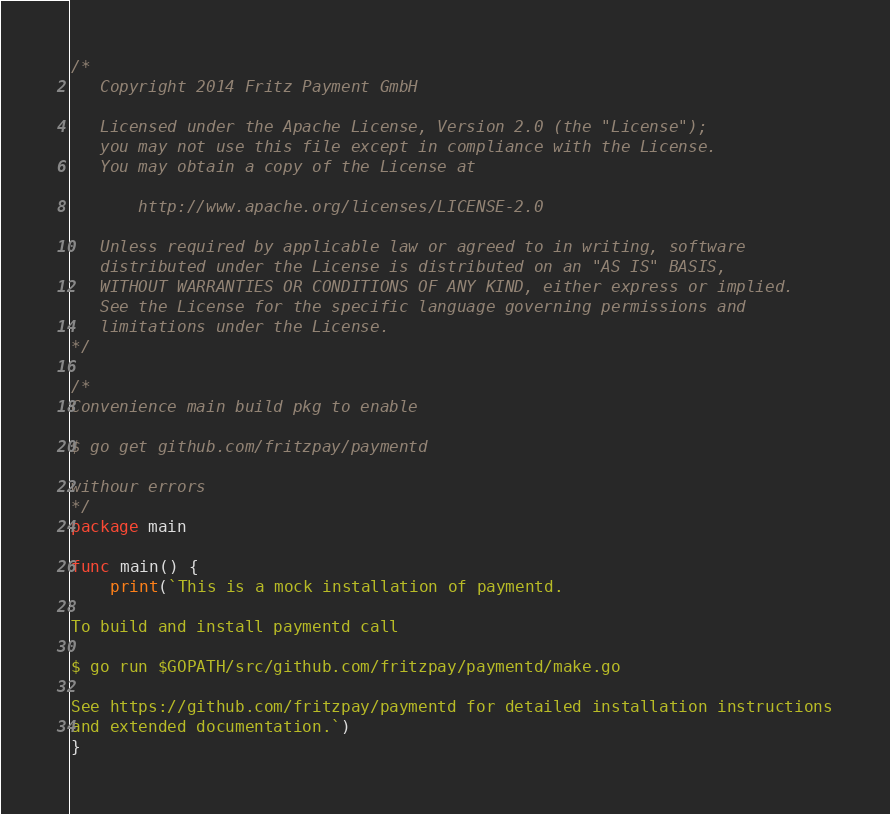Convert code to text. <code><loc_0><loc_0><loc_500><loc_500><_Go_>/*
   Copyright 2014 Fritz Payment GmbH

   Licensed under the Apache License, Version 2.0 (the "License");
   you may not use this file except in compliance with the License.
   You may obtain a copy of the License at

       http://www.apache.org/licenses/LICENSE-2.0

   Unless required by applicable law or agreed to in writing, software
   distributed under the License is distributed on an "AS IS" BASIS,
   WITHOUT WARRANTIES OR CONDITIONS OF ANY KIND, either express or implied.
   See the License for the specific language governing permissions and
   limitations under the License.
*/

/*
Convenience main build pkg to enable

$ go get github.com/fritzpay/paymentd

withour errors
*/
package main

func main() {
	print(`This is a mock installation of paymentd.

To build and install paymentd call

$ go run $GOPATH/src/github.com/fritzpay/paymentd/make.go

See https://github.com/fritzpay/paymentd for detailed installation instructions
and extended documentation.`)
}
</code> 